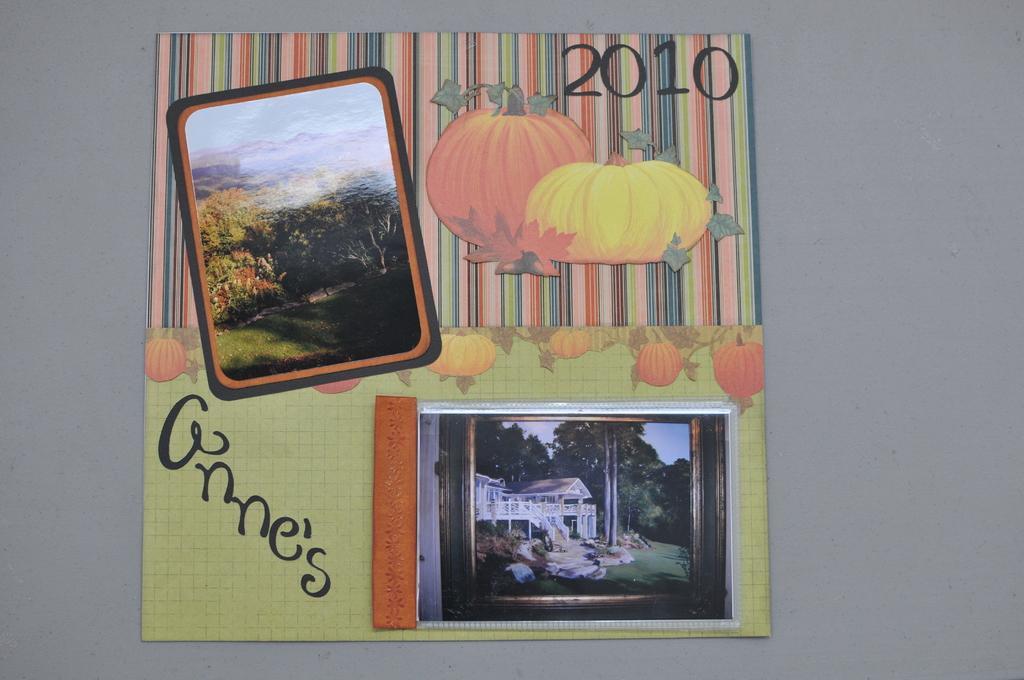Can you describe this image briefly? In this image we can see a paper with some designs. On that there are two images. In the top image there are trees. In the bottom image there are trees and a building. Also something is written on the paper. In the back there is a surface. 